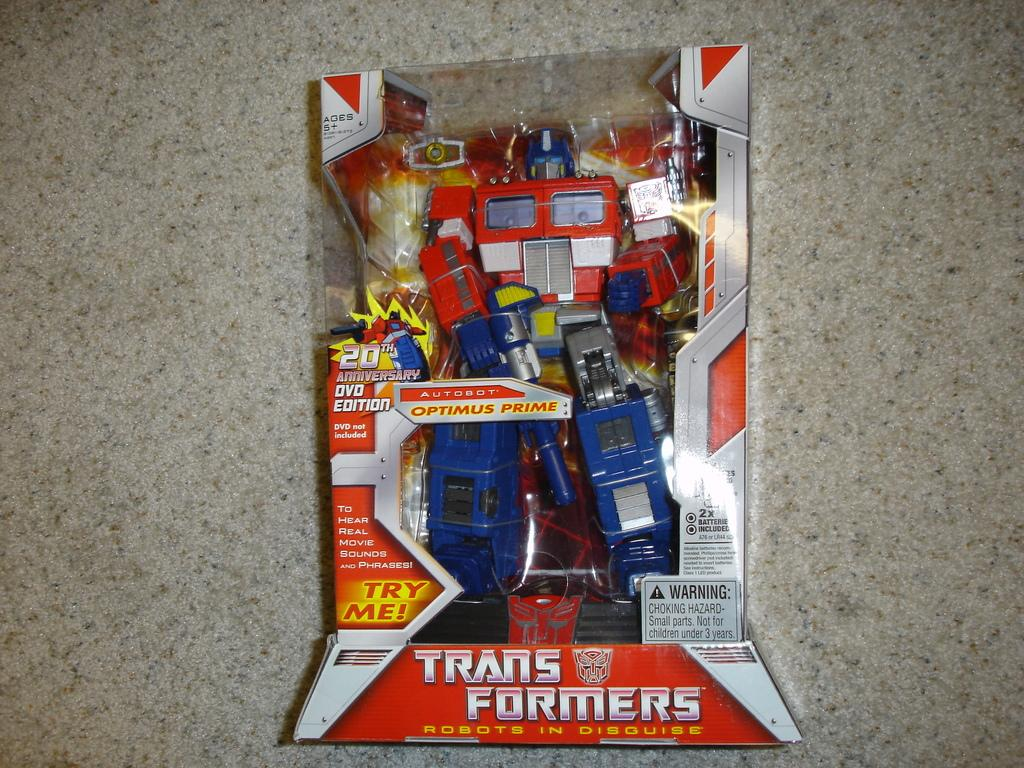<image>
Offer a succinct explanation of the picture presented. A Transformers toy in its package resting on the floor. 